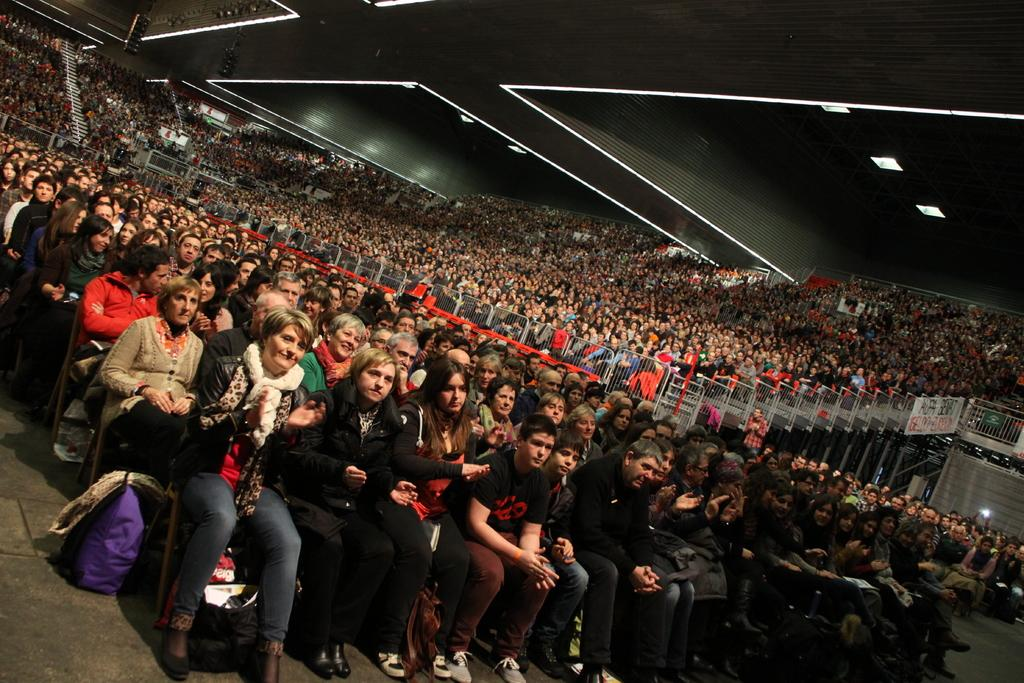How many people are in the image? There are many people in the image. What are the people doing in the image? The people are sitting on chairs. What type of location does the image resemble? The setting resembles a stadium. What is visible on top of the stadium in the image? There is a roof visible in the image, and there are lights on the roof. What is visible at the bottom of the image? There is a floor visible in the image. How many pigs are visible on the floor in the image? There are no pigs visible on the floor in the image. What type of pot is being used by the people in the image? There is no pot present in the image. 